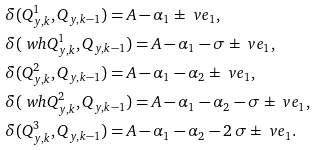<formula> <loc_0><loc_0><loc_500><loc_500>& \delta ( Q _ { y , k } ^ { 1 } , Q _ { y , k - 1 } ) = A - \alpha _ { 1 } \pm \ v e _ { 1 } , \\ & \delta ( \ w h { Q } _ { y , k } ^ { 1 } , Q _ { y , k - 1 } ) = A - \alpha _ { 1 } - \sigma \pm \ v e _ { 1 } , \\ & \delta ( Q _ { y , k } ^ { 2 } , Q _ { y , k - 1 } ) = A - \alpha _ { 1 } - \alpha _ { 2 } \pm \ v e _ { 1 } , \\ & \delta ( \ w h { Q } _ { y , k } ^ { 2 } , Q _ { y , k - 1 } ) = A - \alpha _ { 1 } - \alpha _ { 2 } - \sigma \pm \ v e _ { 1 } , \\ & \delta ( Q _ { y , k } ^ { 3 } , Q _ { y , k - 1 } ) = A - \alpha _ { 1 } - \alpha _ { 2 } - 2 \, \sigma \pm \ v e _ { 1 } .</formula> 